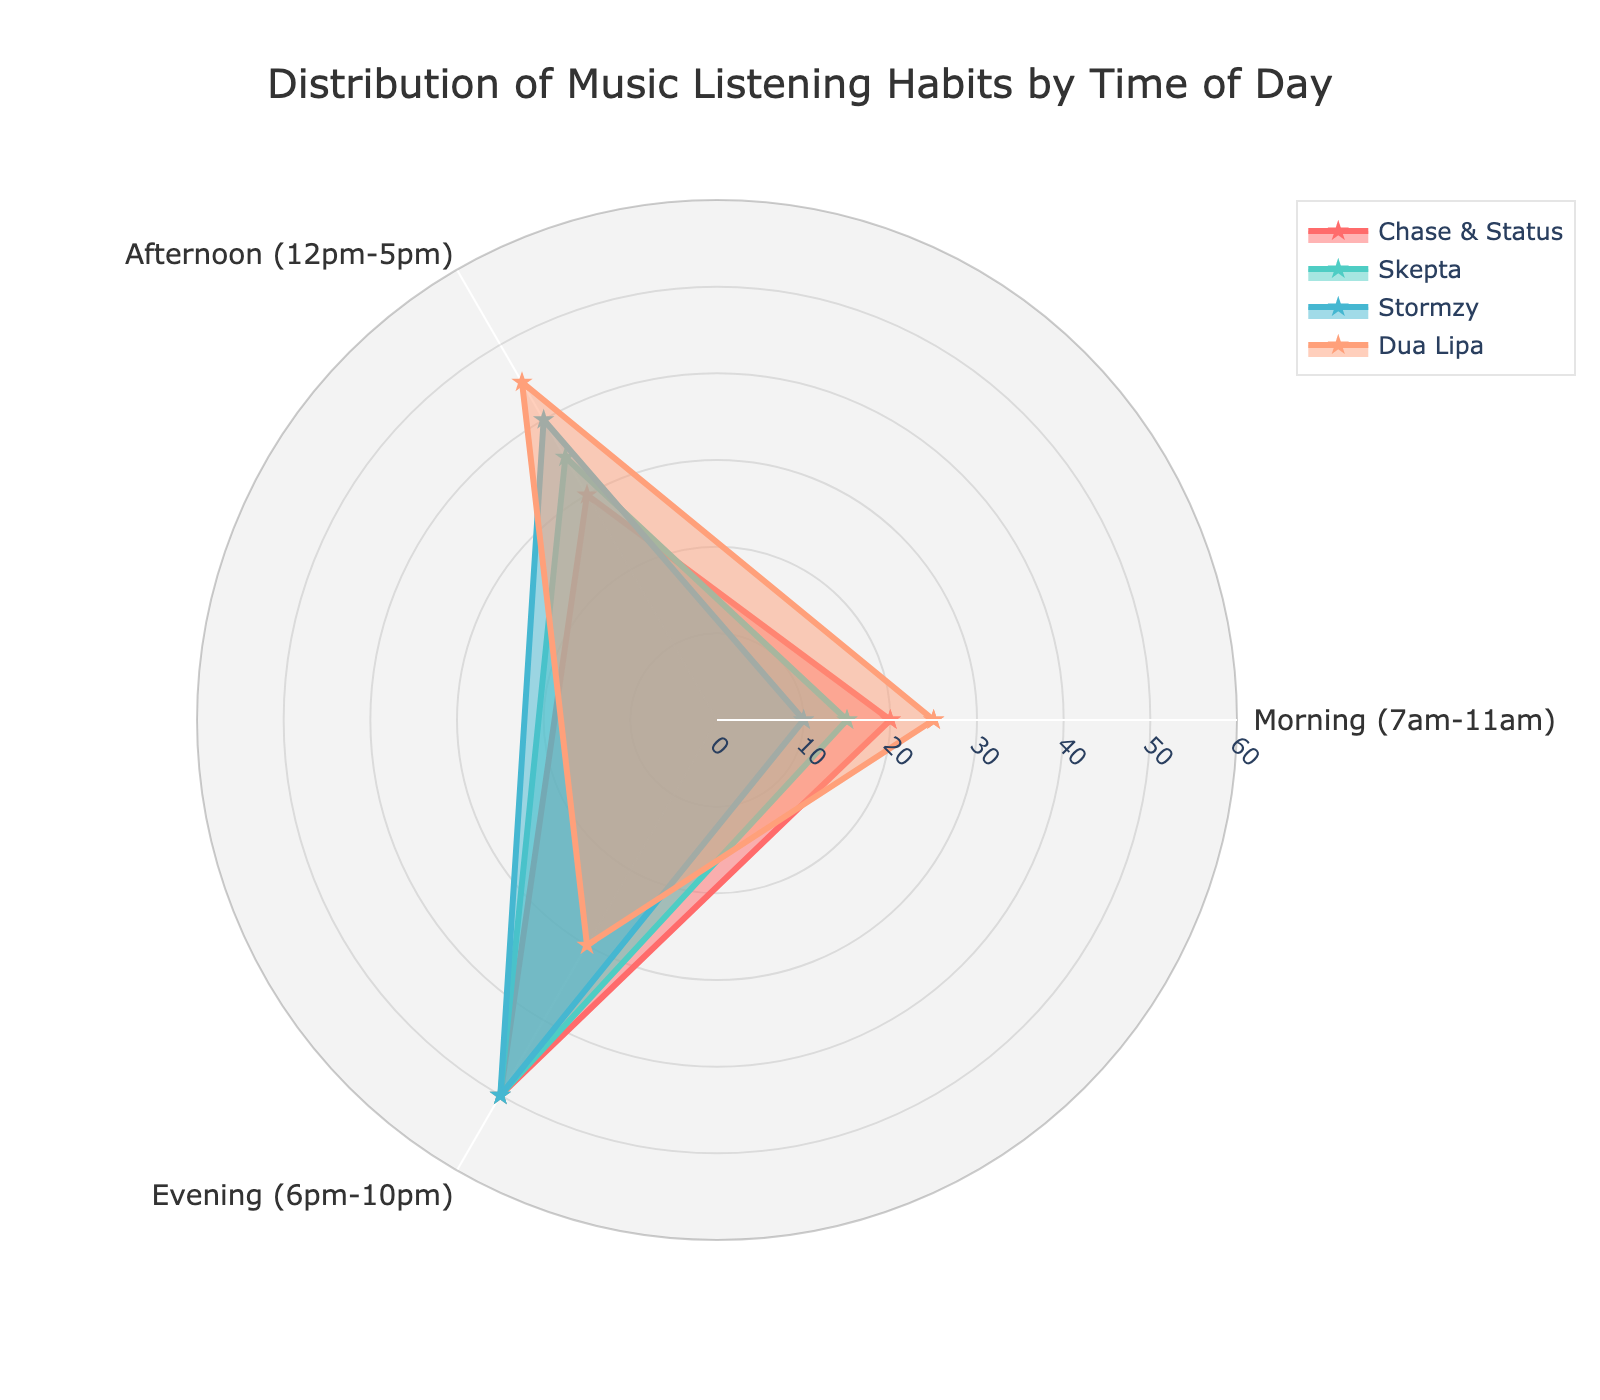what is the title of the radar chart? The title is typically shown at the top of the radar chart, indicating what the chart represents. In this case, it is "Distribution of Music Listening Habits by Time of Day".
Answer: Distribution of Music Listening Habits by Time of Day Which artist has the highest listening habit in the morning? By looking at the morning values on the radar chart, which ranges from 7am to 11am, Chase & Status has the highest value of 20.
Answer: Chase & Status How does Dua Lipa's listening habits in the evening compare to those of Chase & Status? In the evening values (6pm-10pm), Dua Lipa has a value of 30, whereas Chase & Status has a value of 50. Therefore, Chase & Status has higher listening habits than Dua Lipa in the evening.
Answer: Chase & Status has higher listening habits Which time of day has the highest listening habits for Stormzy? On the radar chart, checking the values for morning, afternoon, and evening for Stormzy, the evening value is the highest at 50.
Answer: Evening What is the average listening habit value for Skepta across the three time periods? Sum the values of Skepta in the morning (15), afternoon (35), and evening (50), then divide by the number of periods (3): (15 + 35 + 50) / 3 = 33.33.
Answer: 33.33 Which artist has more balanced listening habits across all three periods? A balanced listening habit means the values are closer to each other across morning, afternoon, and evening. Dua Lipa has values 25, 45, and 30, respectively, which are relatively close compared to other artists.
Answer: Dua Lipa Compare the total listening habits in the afternoon for all artists. Sum the afternoon values for Chase & Status (30), Skepta (35), Stormzy (40), and Dua Lipa (45). So, 30 + 35 + 40 + 45 = 150.
Answer: 150 What is the total listening habit value for Chase & Status across all time periods? Add Chase & Status values for all periods: 20 (morning) + 30 (afternoon) + 50 (evening) = 100.
Answer: 100 Who has higher listening habits in the morning: Skepta or Stormzy? Comparing the morning values of Skepta (15) and Stormzy (10), Skepta has a higher listening habit.
Answer: Skepta 